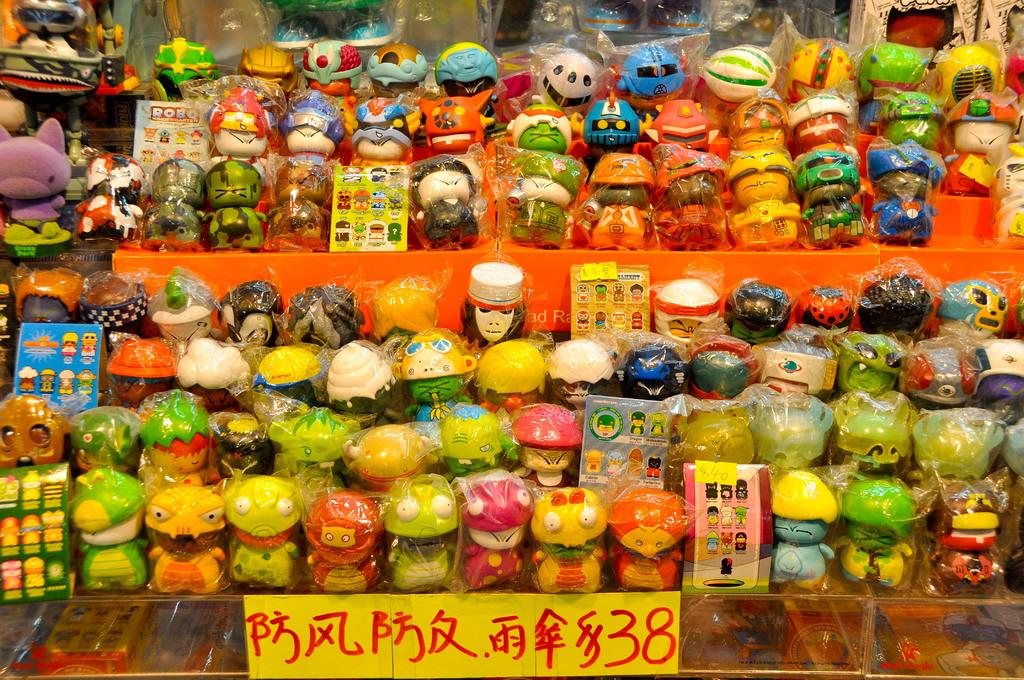What is the cost of the products on the table?
Your response must be concise. 38. 